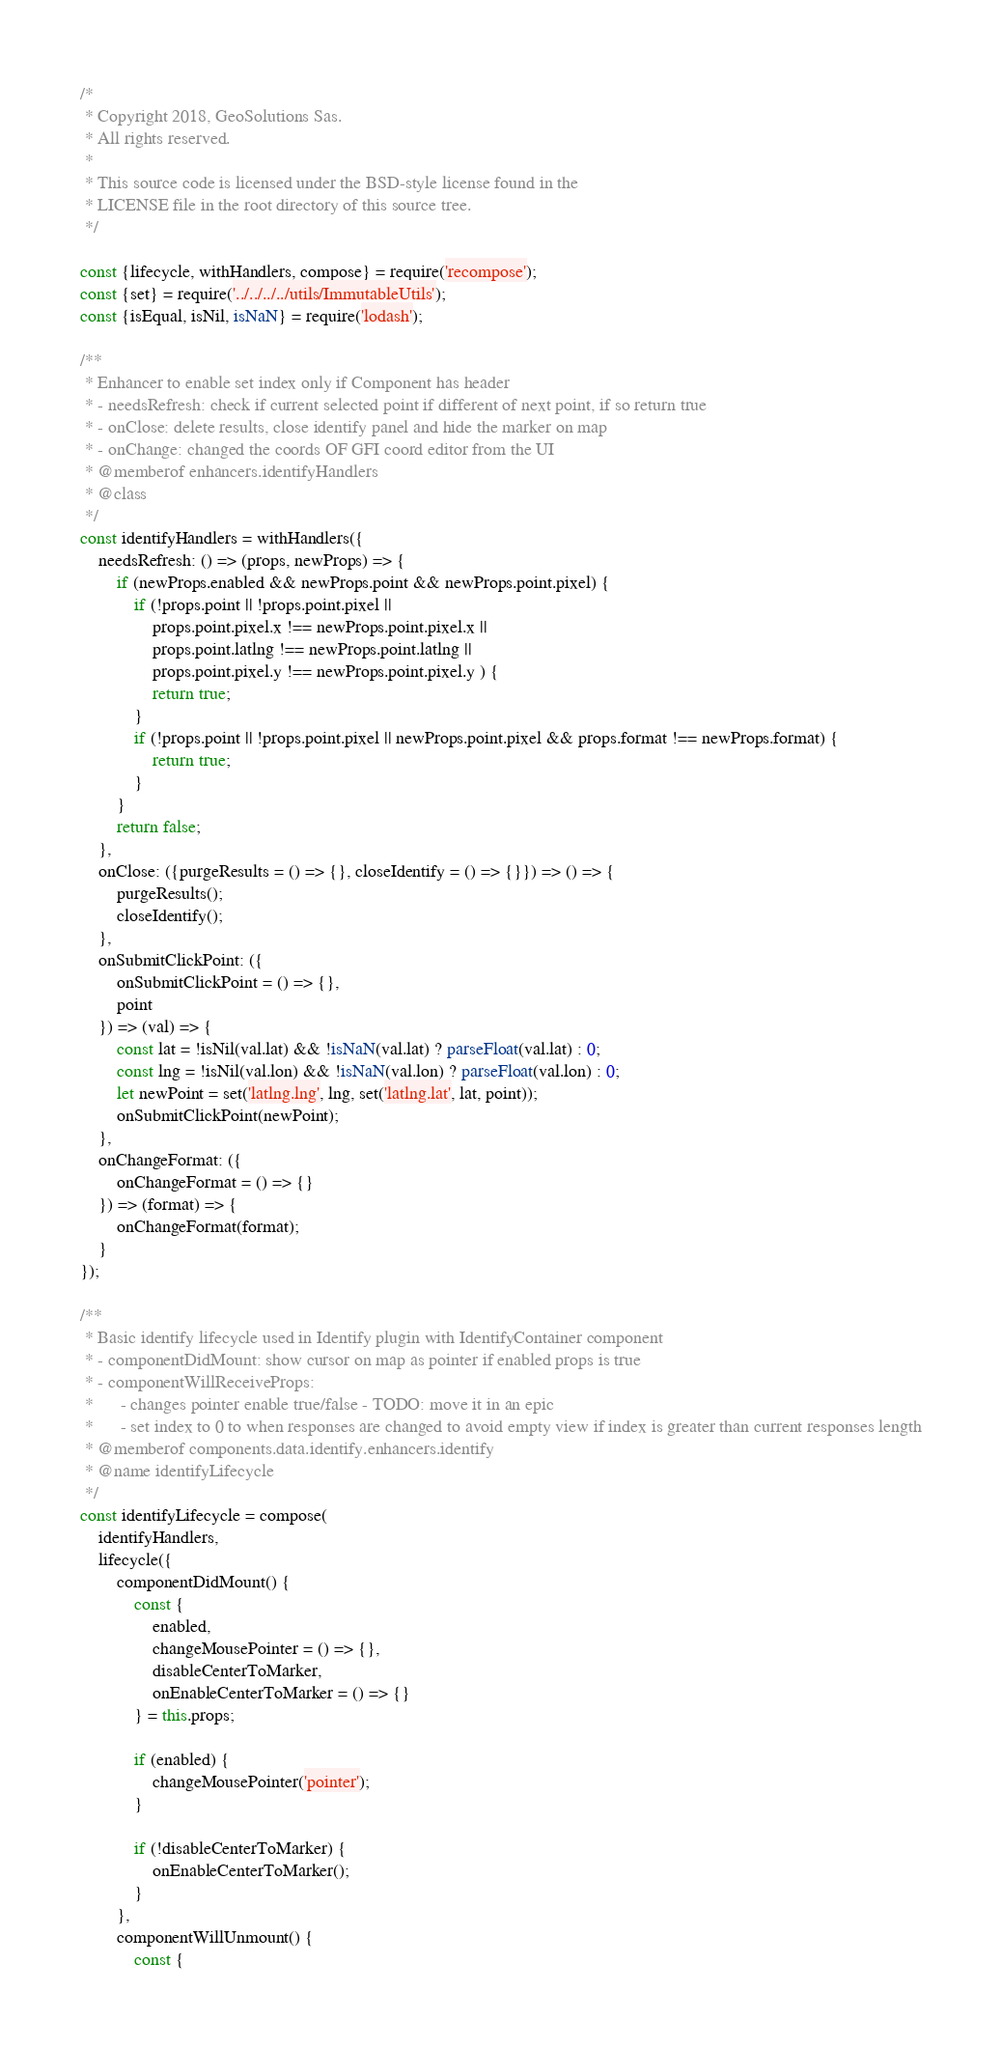Convert code to text. <code><loc_0><loc_0><loc_500><loc_500><_JavaScript_>/*
 * Copyright 2018, GeoSolutions Sas.
 * All rights reserved.
 *
 * This source code is licensed under the BSD-style license found in the
 * LICENSE file in the root directory of this source tree.
 */

const {lifecycle, withHandlers, compose} = require('recompose');
const {set} = require('../../../../utils/ImmutableUtils');
const {isEqual, isNil, isNaN} = require('lodash');

/**
 * Enhancer to enable set index only if Component has header
 * - needsRefresh: check if current selected point if different of next point, if so return true
 * - onClose: delete results, close identify panel and hide the marker on map
 * - onChange: changed the coords OF GFI coord editor from the UI
 * @memberof enhancers.identifyHandlers
 * @class
 */
const identifyHandlers = withHandlers({
    needsRefresh: () => (props, newProps) => {
        if (newProps.enabled && newProps.point && newProps.point.pixel) {
            if (!props.point || !props.point.pixel ||
                props.point.pixel.x !== newProps.point.pixel.x ||
                props.point.latlng !== newProps.point.latlng ||
                props.point.pixel.y !== newProps.point.pixel.y ) {
                return true;
            }
            if (!props.point || !props.point.pixel || newProps.point.pixel && props.format !== newProps.format) {
                return true;
            }
        }
        return false;
    },
    onClose: ({purgeResults = () => {}, closeIdentify = () => {}}) => () => {
        purgeResults();
        closeIdentify();
    },
    onSubmitClickPoint: ({
        onSubmitClickPoint = () => {},
        point
    }) => (val) => {
        const lat = !isNil(val.lat) && !isNaN(val.lat) ? parseFloat(val.lat) : 0;
        const lng = !isNil(val.lon) && !isNaN(val.lon) ? parseFloat(val.lon) : 0;
        let newPoint = set('latlng.lng', lng, set('latlng.lat', lat, point));
        onSubmitClickPoint(newPoint);
    },
    onChangeFormat: ({
        onChangeFormat = () => {}
    }) => (format) => {
        onChangeFormat(format);
    }
});

/**
 * Basic identify lifecycle used in Identify plugin with IdentifyContainer component
 * - componentDidMount: show cursor on map as pointer if enabled props is true
 * - componentWillReceiveProps:
 *      - changes pointer enable true/false - TODO: move it in an epic
 *      - set index to 0 to when responses are changed to avoid empty view if index is greater than current responses length
 * @memberof components.data.identify.enhancers.identify
 * @name identifyLifecycle
 */
const identifyLifecycle = compose(
    identifyHandlers,
    lifecycle({
        componentDidMount() {
            const {
                enabled,
                changeMousePointer = () => {},
                disableCenterToMarker,
                onEnableCenterToMarker = () => {}
            } = this.props;

            if (enabled) {
                changeMousePointer('pointer');
            }

            if (!disableCenterToMarker) {
                onEnableCenterToMarker();
            }
        },
        componentWillUnmount() {
            const {</code> 